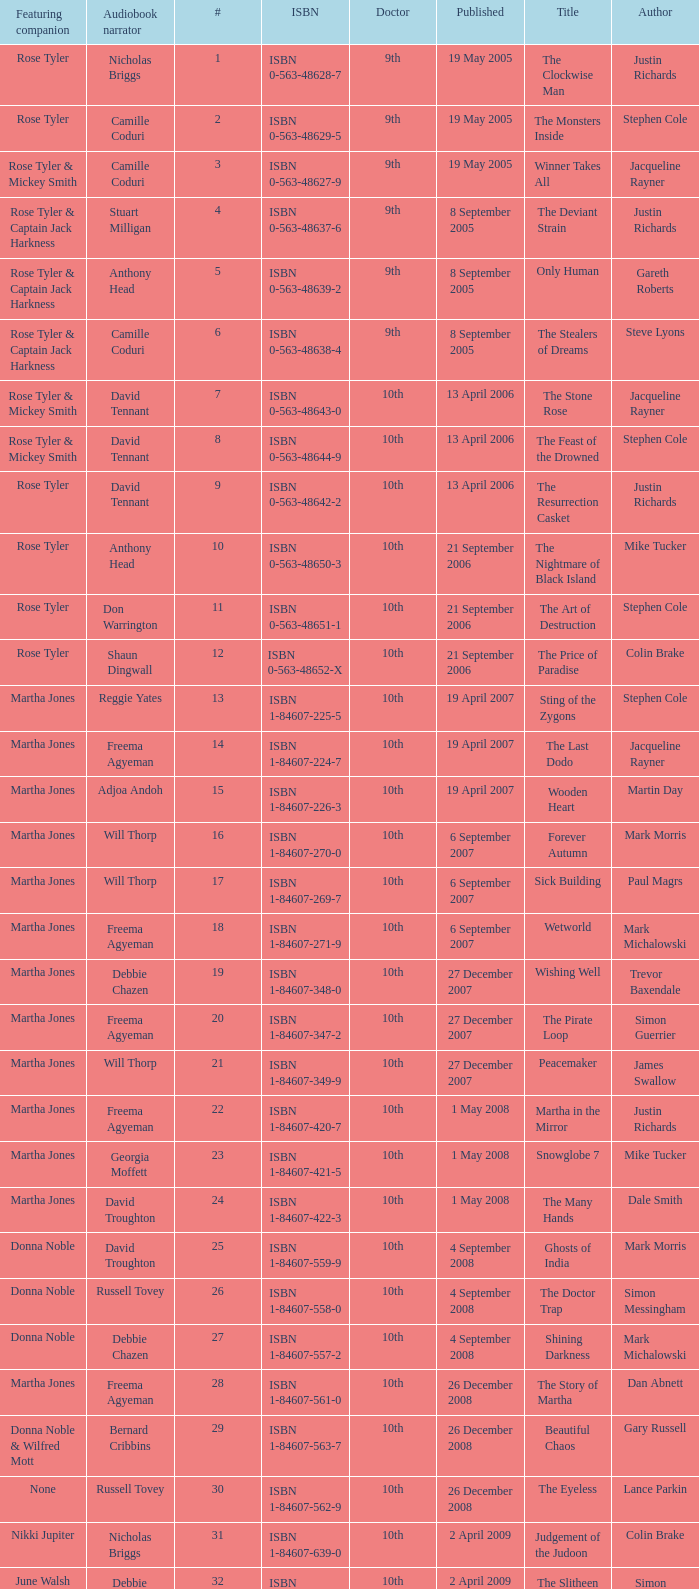What is the title of book number 7? The Stone Rose. 